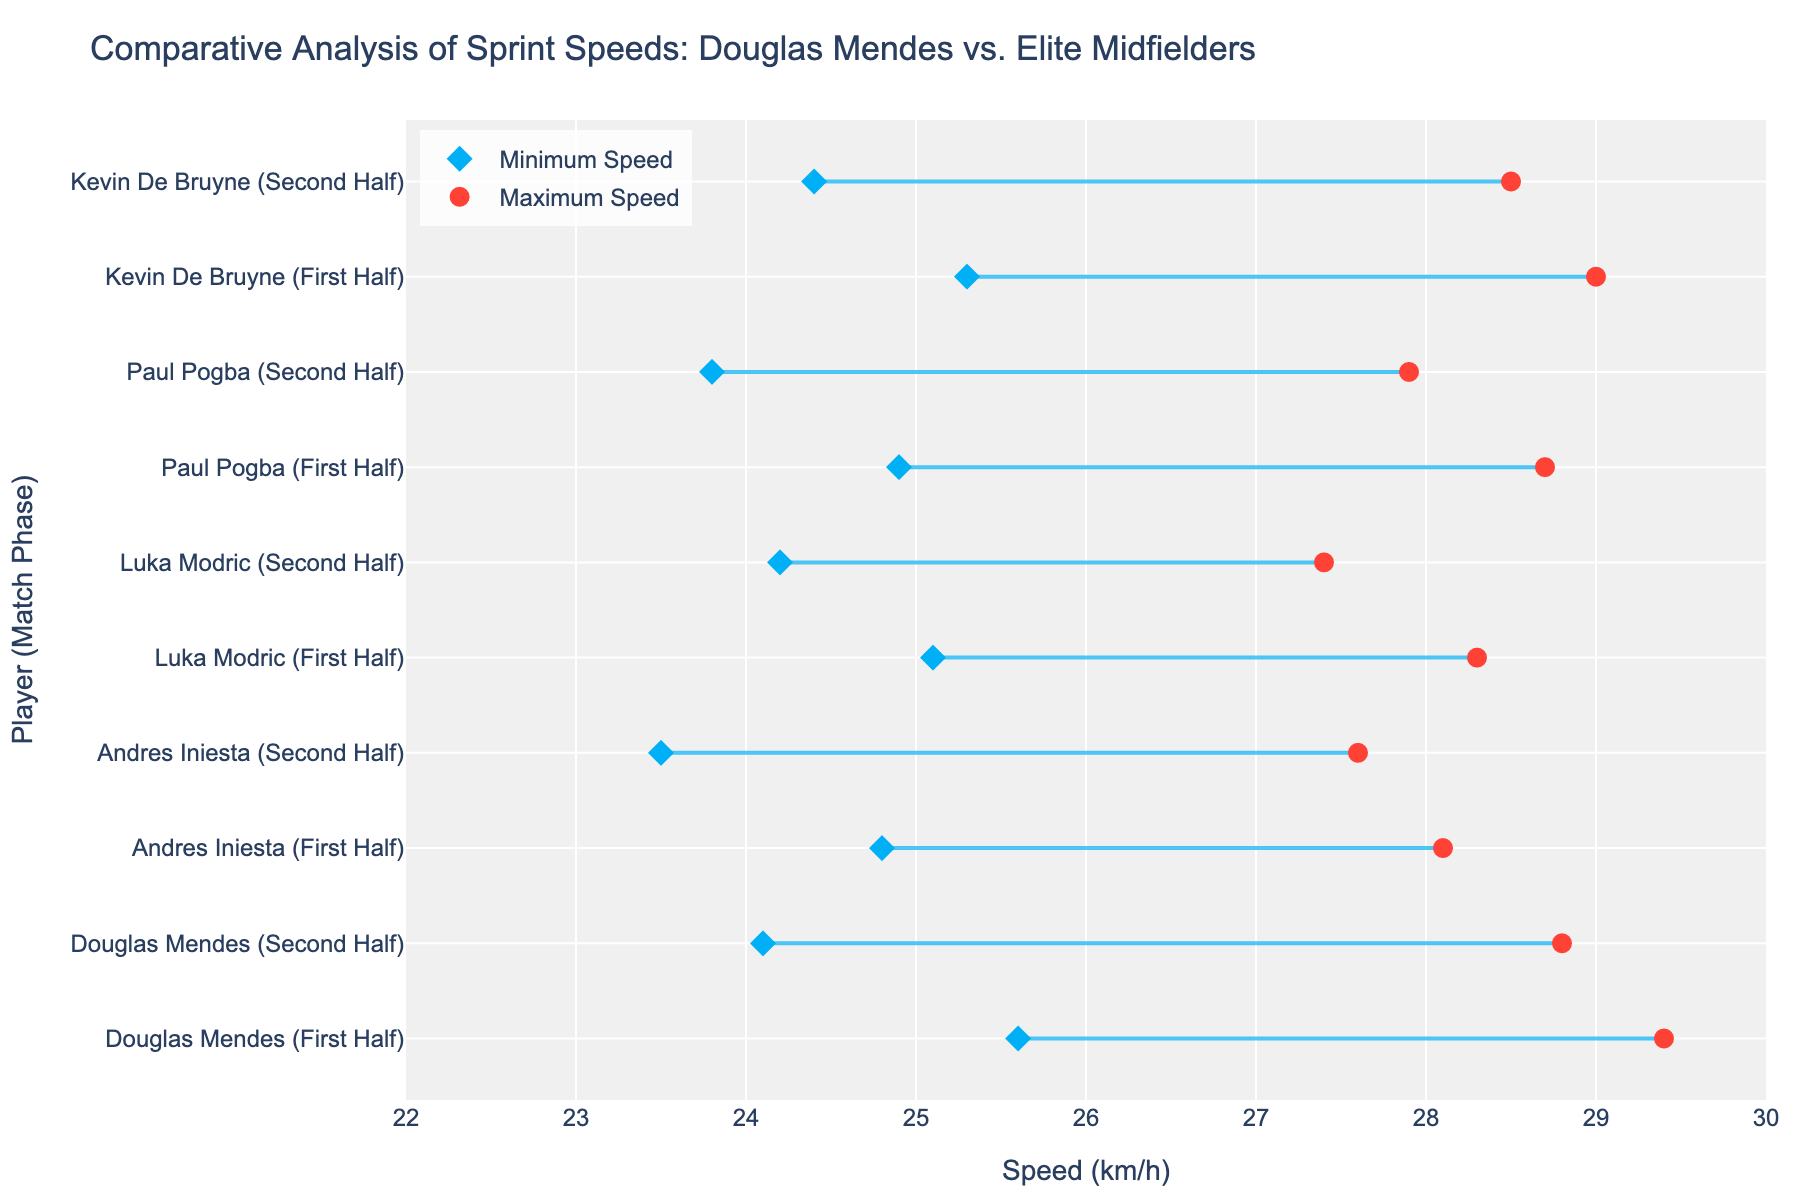How many players are shown in the figure? There are five distinct players shown in the figure. Each player’s name appears twice because they are separated by the phase (First Half, Second Half).
Answer: 5 What is the minimum sprint speed of Douglas Mendes in the second half? Look at the data points for Douglas Mendes (Second Half) and identify the minimum speed value, which is represented by the leftmost dot on the line.
Answer: 24.1 km/h What is the maximum sprint speed difference between the first half and the second half for any player? For each player, subtract the maximum speed in the Second Half from the maximum speed in the First Half to find the difference. The differences are Douglas Mendes: 29.4 - 28.8 = 0.6, Andres Iniesta: 28.1 - 27.6 = 0.5, Luka Modric: 28.3 - 27.4 = 0.9, Paul Pogba: 28.7 - 27.9 = 0.8, Kevin De Bruyne: 29.0 - 28.5 = 0.5. The largest difference is 0.9 km/h for Luka Modric.
Answer: 0.9 km/h Which player has the highest minimum sprint speed in both halves? Observe the minimum speed dots for all players in both halves. Kevin De Bruyne in the first half has the highest minimum sprint speed shown at 25.3 km/h.
Answer: Kevin De Bruyne Is Douglas Mendes’ minimum speed in the first half better than any player's maximum speed in the second half? Check the minimum speed dot for Douglas Mendes in the first half (25.6 km/h) and compare it with the maximum speed dots of all players in the second half. Douglas Mendes' minimum speed is greater than Andres Iniesta’s (27.6), Luka Modric’s (27.4), Paul Pogba’s (27.9), and only slightly lower than Kevin De Bruyne’s (28.5).
Answer: Yes On average, was Paul Pogba faster in the first half or in the second half? Calculate the average speed for Paul Pogba in each half. First Half: (24.9 + 28.7) / 2 = 26.8 km/h. Second Half: (23.8 + 27.9) / 2 = 25.85 km/h. The average speed is higher in the first half.
Answer: First Half How does Douglas Mendes’ maximum speed in the first half compare to Kevin De Bruyne’s? Compare the maximum speed dots for both players in the first half, Douglas Mendes (29.4 km/h) and Kevin De Bruyne (29 km/h).
Answer: Higher In which half did Douglas Mendes display a narrower range of sprint speeds? For Douglas Mendes, calculate the range for both halves: First Half: 29.4 - 25.6 = 3.8 km/h. Second Half: 28.8 - 24.1 = 4.7 km/h. The narrower range is in the first half.
Answer: First Half 